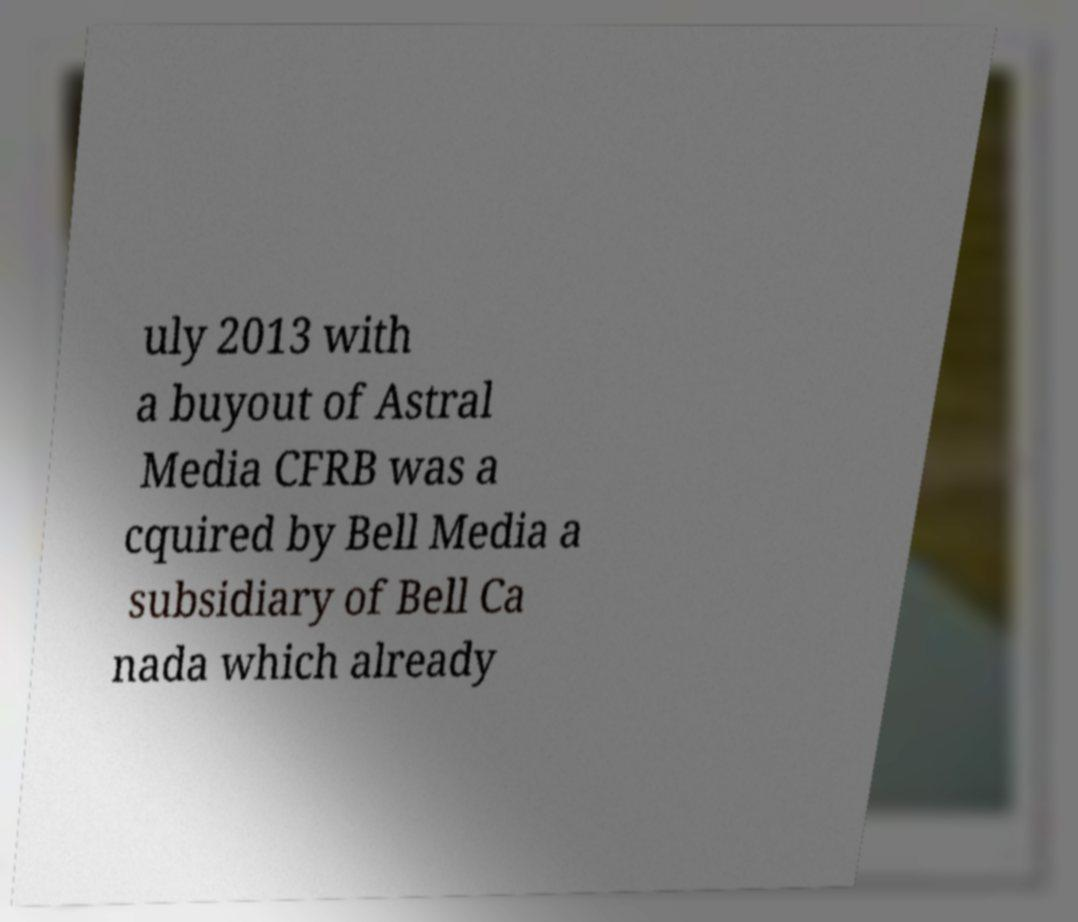Can you read and provide the text displayed in the image?This photo seems to have some interesting text. Can you extract and type it out for me? uly 2013 with a buyout of Astral Media CFRB was a cquired by Bell Media a subsidiary of Bell Ca nada which already 